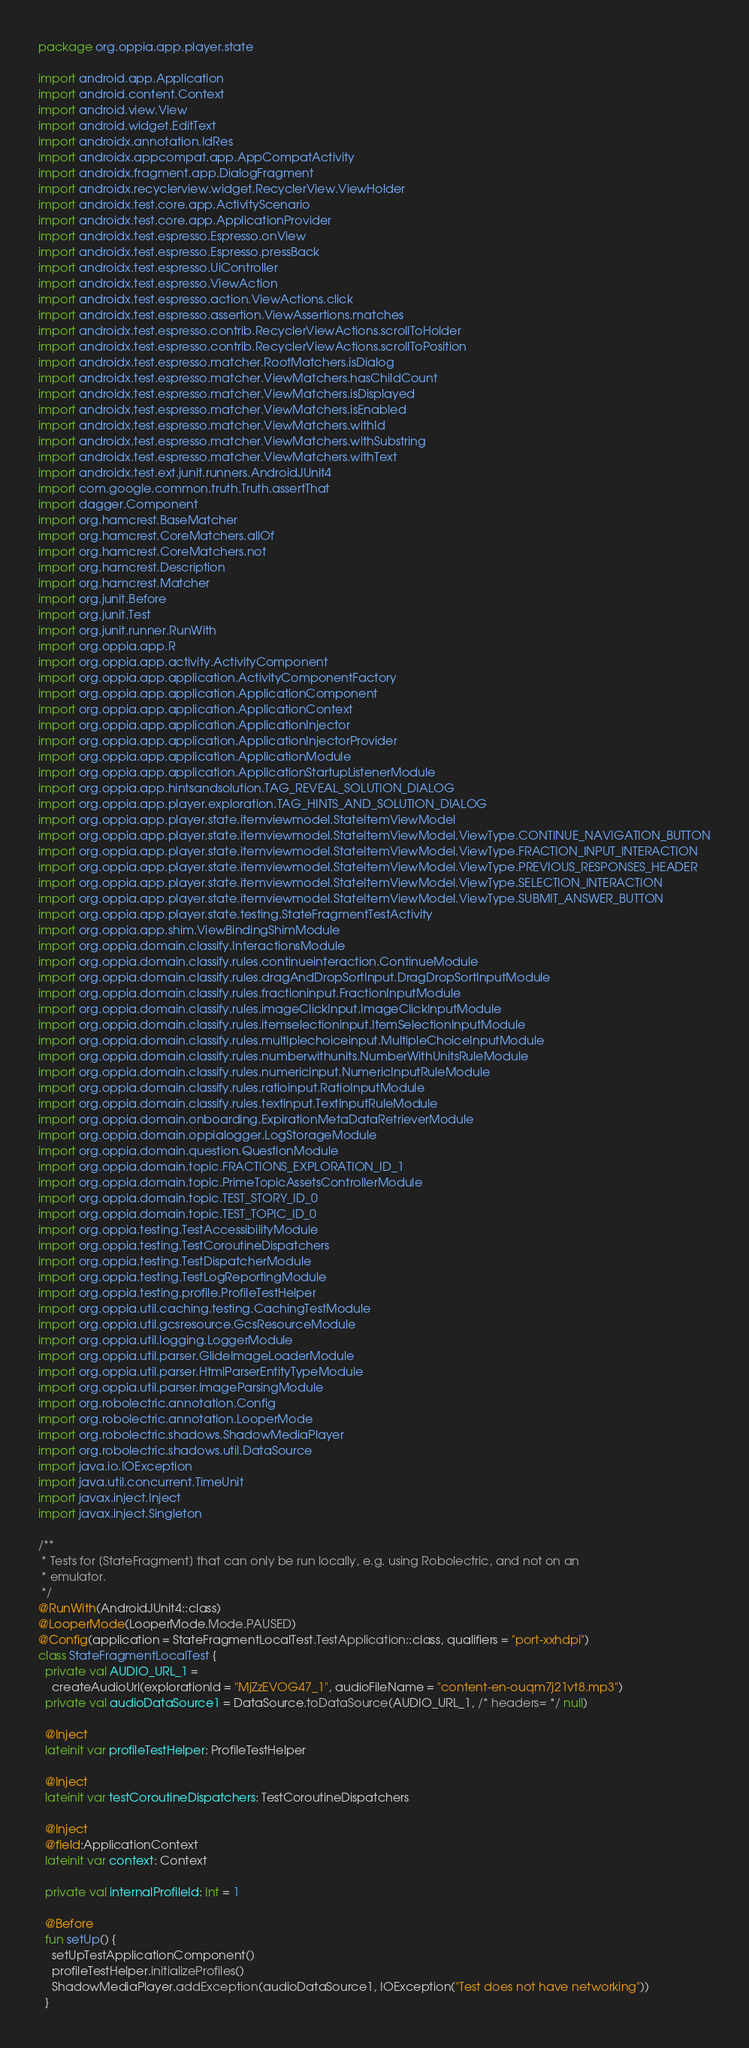Convert code to text. <code><loc_0><loc_0><loc_500><loc_500><_Kotlin_>package org.oppia.app.player.state

import android.app.Application
import android.content.Context
import android.view.View
import android.widget.EditText
import androidx.annotation.IdRes
import androidx.appcompat.app.AppCompatActivity
import androidx.fragment.app.DialogFragment
import androidx.recyclerview.widget.RecyclerView.ViewHolder
import androidx.test.core.app.ActivityScenario
import androidx.test.core.app.ApplicationProvider
import androidx.test.espresso.Espresso.onView
import androidx.test.espresso.Espresso.pressBack
import androidx.test.espresso.UiController
import androidx.test.espresso.ViewAction
import androidx.test.espresso.action.ViewActions.click
import androidx.test.espresso.assertion.ViewAssertions.matches
import androidx.test.espresso.contrib.RecyclerViewActions.scrollToHolder
import androidx.test.espresso.contrib.RecyclerViewActions.scrollToPosition
import androidx.test.espresso.matcher.RootMatchers.isDialog
import androidx.test.espresso.matcher.ViewMatchers.hasChildCount
import androidx.test.espresso.matcher.ViewMatchers.isDisplayed
import androidx.test.espresso.matcher.ViewMatchers.isEnabled
import androidx.test.espresso.matcher.ViewMatchers.withId
import androidx.test.espresso.matcher.ViewMatchers.withSubstring
import androidx.test.espresso.matcher.ViewMatchers.withText
import androidx.test.ext.junit.runners.AndroidJUnit4
import com.google.common.truth.Truth.assertThat
import dagger.Component
import org.hamcrest.BaseMatcher
import org.hamcrest.CoreMatchers.allOf
import org.hamcrest.CoreMatchers.not
import org.hamcrest.Description
import org.hamcrest.Matcher
import org.junit.Before
import org.junit.Test
import org.junit.runner.RunWith
import org.oppia.app.R
import org.oppia.app.activity.ActivityComponent
import org.oppia.app.application.ActivityComponentFactory
import org.oppia.app.application.ApplicationComponent
import org.oppia.app.application.ApplicationContext
import org.oppia.app.application.ApplicationInjector
import org.oppia.app.application.ApplicationInjectorProvider
import org.oppia.app.application.ApplicationModule
import org.oppia.app.application.ApplicationStartupListenerModule
import org.oppia.app.hintsandsolution.TAG_REVEAL_SOLUTION_DIALOG
import org.oppia.app.player.exploration.TAG_HINTS_AND_SOLUTION_DIALOG
import org.oppia.app.player.state.itemviewmodel.StateItemViewModel
import org.oppia.app.player.state.itemviewmodel.StateItemViewModel.ViewType.CONTINUE_NAVIGATION_BUTTON
import org.oppia.app.player.state.itemviewmodel.StateItemViewModel.ViewType.FRACTION_INPUT_INTERACTION
import org.oppia.app.player.state.itemviewmodel.StateItemViewModel.ViewType.PREVIOUS_RESPONSES_HEADER
import org.oppia.app.player.state.itemviewmodel.StateItemViewModel.ViewType.SELECTION_INTERACTION
import org.oppia.app.player.state.itemviewmodel.StateItemViewModel.ViewType.SUBMIT_ANSWER_BUTTON
import org.oppia.app.player.state.testing.StateFragmentTestActivity
import org.oppia.app.shim.ViewBindingShimModule
import org.oppia.domain.classify.InteractionsModule
import org.oppia.domain.classify.rules.continueinteraction.ContinueModule
import org.oppia.domain.classify.rules.dragAndDropSortInput.DragDropSortInputModule
import org.oppia.domain.classify.rules.fractioninput.FractionInputModule
import org.oppia.domain.classify.rules.imageClickInput.ImageClickInputModule
import org.oppia.domain.classify.rules.itemselectioninput.ItemSelectionInputModule
import org.oppia.domain.classify.rules.multiplechoiceinput.MultipleChoiceInputModule
import org.oppia.domain.classify.rules.numberwithunits.NumberWithUnitsRuleModule
import org.oppia.domain.classify.rules.numericinput.NumericInputRuleModule
import org.oppia.domain.classify.rules.ratioinput.RatioInputModule
import org.oppia.domain.classify.rules.textinput.TextInputRuleModule
import org.oppia.domain.onboarding.ExpirationMetaDataRetrieverModule
import org.oppia.domain.oppialogger.LogStorageModule
import org.oppia.domain.question.QuestionModule
import org.oppia.domain.topic.FRACTIONS_EXPLORATION_ID_1
import org.oppia.domain.topic.PrimeTopicAssetsControllerModule
import org.oppia.domain.topic.TEST_STORY_ID_0
import org.oppia.domain.topic.TEST_TOPIC_ID_0
import org.oppia.testing.TestAccessibilityModule
import org.oppia.testing.TestCoroutineDispatchers
import org.oppia.testing.TestDispatcherModule
import org.oppia.testing.TestLogReportingModule
import org.oppia.testing.profile.ProfileTestHelper
import org.oppia.util.caching.testing.CachingTestModule
import org.oppia.util.gcsresource.GcsResourceModule
import org.oppia.util.logging.LoggerModule
import org.oppia.util.parser.GlideImageLoaderModule
import org.oppia.util.parser.HtmlParserEntityTypeModule
import org.oppia.util.parser.ImageParsingModule
import org.robolectric.annotation.Config
import org.robolectric.annotation.LooperMode
import org.robolectric.shadows.ShadowMediaPlayer
import org.robolectric.shadows.util.DataSource
import java.io.IOException
import java.util.concurrent.TimeUnit
import javax.inject.Inject
import javax.inject.Singleton

/**
 * Tests for [StateFragment] that can only be run locally, e.g. using Robolectric, and not on an
 * emulator.
 */
@RunWith(AndroidJUnit4::class)
@LooperMode(LooperMode.Mode.PAUSED)
@Config(application = StateFragmentLocalTest.TestApplication::class, qualifiers = "port-xxhdpi")
class StateFragmentLocalTest {
  private val AUDIO_URL_1 =
    createAudioUrl(explorationId = "MjZzEVOG47_1", audioFileName = "content-en-ouqm7j21vt8.mp3")
  private val audioDataSource1 = DataSource.toDataSource(AUDIO_URL_1, /* headers= */ null)

  @Inject
  lateinit var profileTestHelper: ProfileTestHelper

  @Inject
  lateinit var testCoroutineDispatchers: TestCoroutineDispatchers

  @Inject
  @field:ApplicationContext
  lateinit var context: Context

  private val internalProfileId: Int = 1

  @Before
  fun setUp() {
    setUpTestApplicationComponent()
    profileTestHelper.initializeProfiles()
    ShadowMediaPlayer.addException(audioDataSource1, IOException("Test does not have networking"))
  }
</code> 